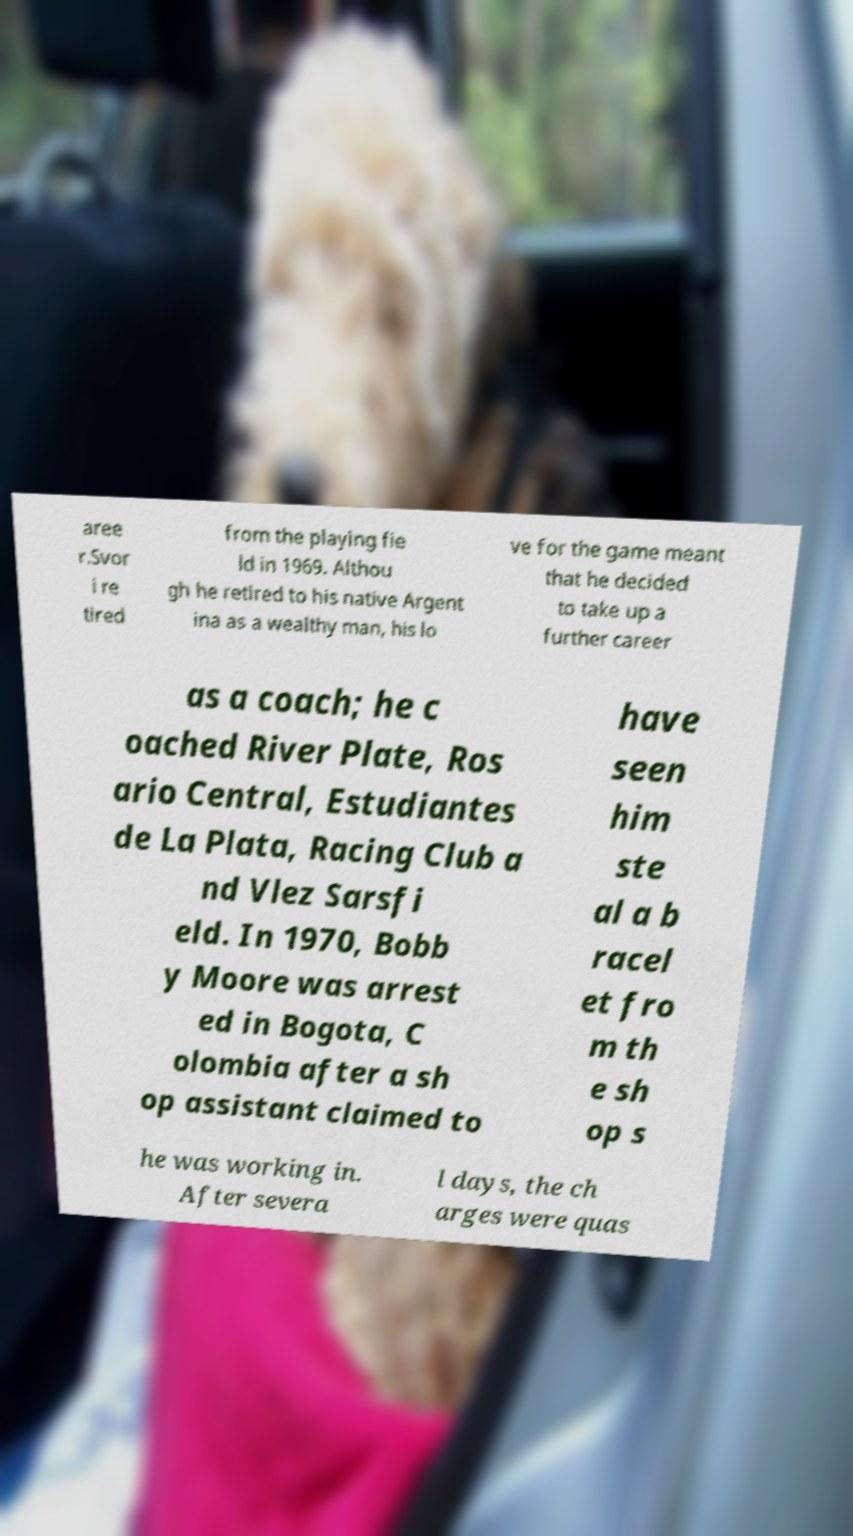What messages or text are displayed in this image? I need them in a readable, typed format. aree r.Svor i re tired from the playing fie ld in 1969. Althou gh he retired to his native Argent ina as a wealthy man, his lo ve for the game meant that he decided to take up a further career as a coach; he c oached River Plate, Ros ario Central, Estudiantes de La Plata, Racing Club a nd Vlez Sarsfi eld. In 1970, Bobb y Moore was arrest ed in Bogota, C olombia after a sh op assistant claimed to have seen him ste al a b racel et fro m th e sh op s he was working in. After severa l days, the ch arges were quas 